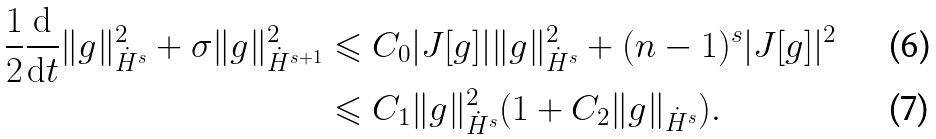<formula> <loc_0><loc_0><loc_500><loc_500>\frac { 1 } { 2 } \frac { \mathrm d } { \mathrm d t } \| g \| ^ { 2 } _ { \dot { H } ^ { s } } + \sigma \| g \| ^ { 2 } _ { \dot { H } ^ { s + 1 } } & \leqslant C _ { 0 } | J [ g ] | \| g \| ^ { 2 } _ { \dot { H } ^ { s } } + ( n - 1 ) ^ { s } | J [ g ] | ^ { 2 } \\ & \leqslant C _ { 1 } \| g \| ^ { 2 } _ { \dot { H } ^ { s } } ( 1 + C _ { 2 } \| g \| _ { \dot { H } ^ { s } } ) .</formula> 